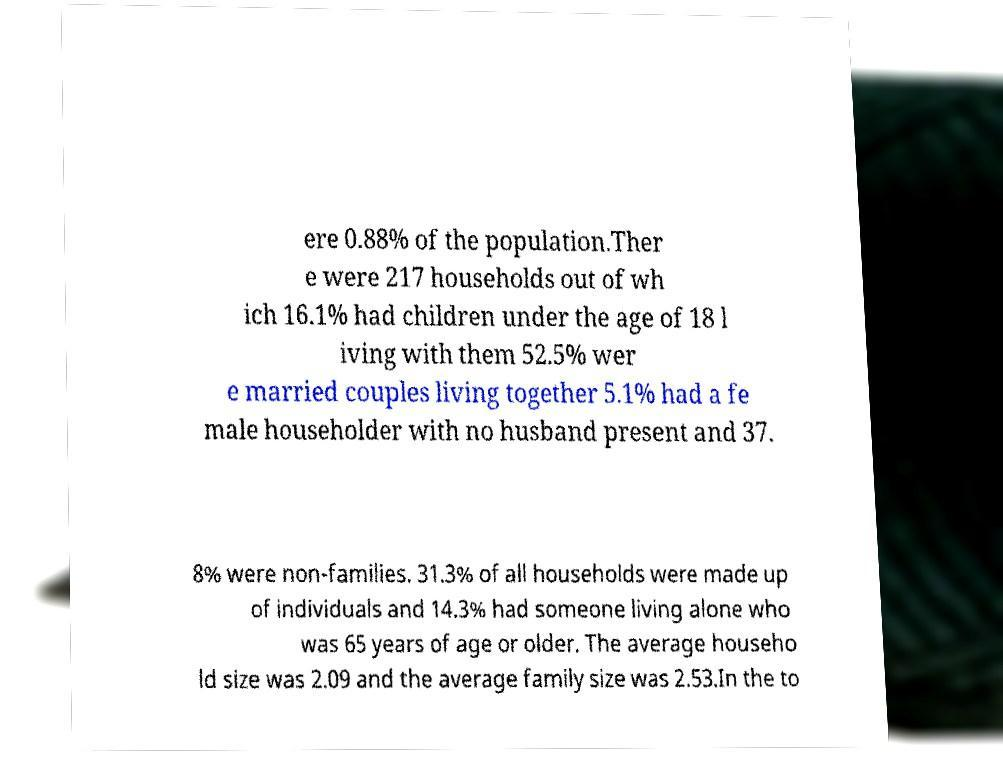There's text embedded in this image that I need extracted. Can you transcribe it verbatim? ere 0.88% of the population.Ther e were 217 households out of wh ich 16.1% had children under the age of 18 l iving with them 52.5% wer e married couples living together 5.1% had a fe male householder with no husband present and 37. 8% were non-families. 31.3% of all households were made up of individuals and 14.3% had someone living alone who was 65 years of age or older. The average househo ld size was 2.09 and the average family size was 2.53.In the to 